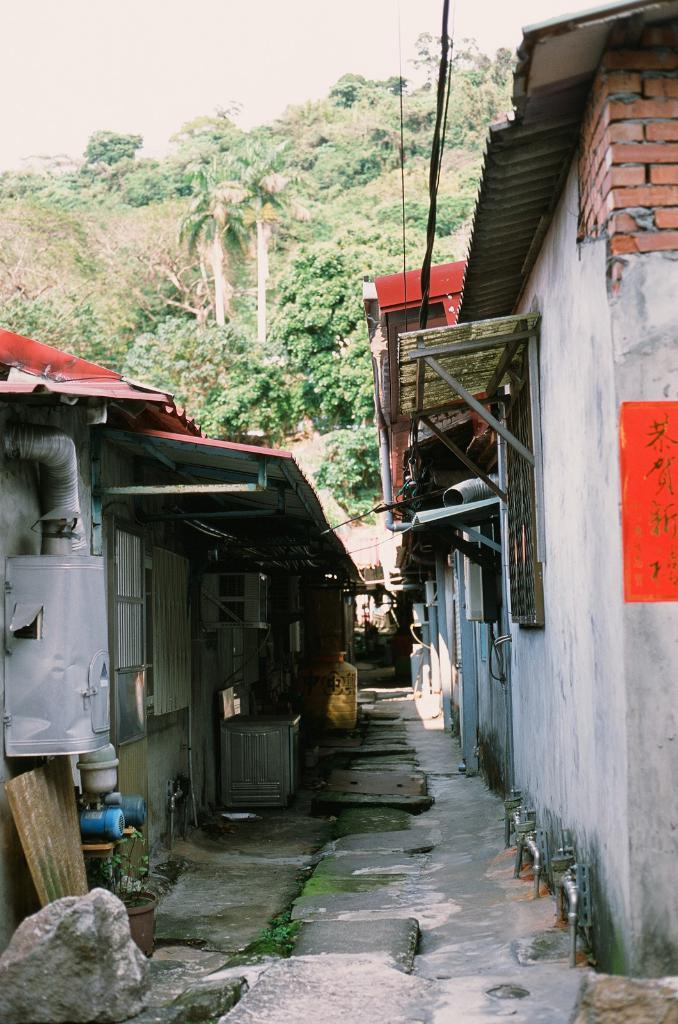What type of structures can be seen in the image? There are buildings in the image. What else can be seen in the image besides the buildings? There are wires and objects on the ground visible in the image. What can be seen in the background of the image? There are trees and the sky visible in the background of the image. What company is responsible for the birth of the objects on the ground in the image? There is no information about a company or the birth of objects in the image. The image simply shows buildings, wires, objects on the ground, trees, and the sky. 